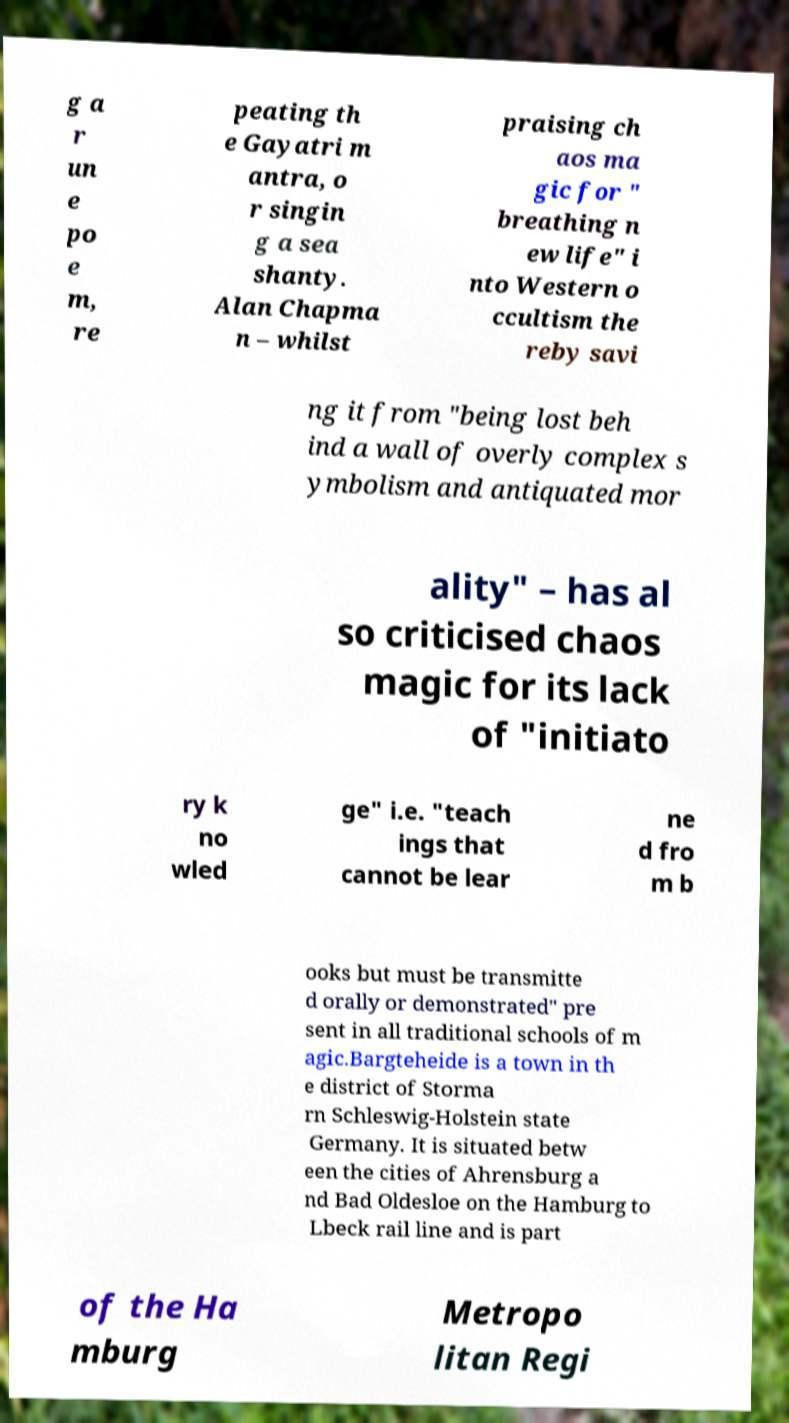Please read and relay the text visible in this image. What does it say? g a r un e po e m, re peating th e Gayatri m antra, o r singin g a sea shanty. Alan Chapma n – whilst praising ch aos ma gic for " breathing n ew life" i nto Western o ccultism the reby savi ng it from "being lost beh ind a wall of overly complex s ymbolism and antiquated mor ality" – has al so criticised chaos magic for its lack of "initiato ry k no wled ge" i.e. "teach ings that cannot be lear ne d fro m b ooks but must be transmitte d orally or demonstrated" pre sent in all traditional schools of m agic.Bargteheide is a town in th e district of Storma rn Schleswig-Holstein state Germany. It is situated betw een the cities of Ahrensburg a nd Bad Oldesloe on the Hamburg to Lbeck rail line and is part of the Ha mburg Metropo litan Regi 